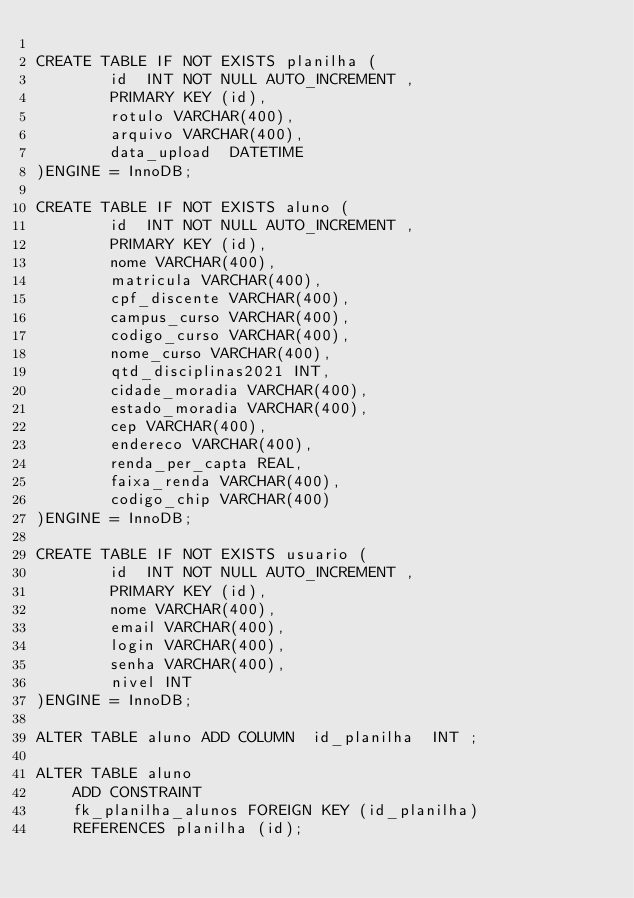Convert code to text. <code><loc_0><loc_0><loc_500><loc_500><_SQL_>
CREATE TABLE IF NOT EXISTS planilha (
        id  INT NOT NULL AUTO_INCREMENT , 
        PRIMARY KEY (id), 
        rotulo VARCHAR(400), 
        arquivo VARCHAR(400), 
        data_upload  DATETIME
)ENGINE = InnoDB;

CREATE TABLE IF NOT EXISTS aluno (
        id  INT NOT NULL AUTO_INCREMENT , 
        PRIMARY KEY (id), 
        nome VARCHAR(400), 
        matricula VARCHAR(400), 
        cpf_discente VARCHAR(400), 
        campus_curso VARCHAR(400), 
        codigo_curso VARCHAR(400), 
        nome_curso VARCHAR(400), 
        qtd_disciplinas2021 INT, 
        cidade_moradia VARCHAR(400), 
        estado_moradia VARCHAR(400), 
        cep VARCHAR(400), 
        endereco VARCHAR(400), 
        renda_per_capta REAL, 
        faixa_renda VARCHAR(400), 
        codigo_chip VARCHAR(400)
)ENGINE = InnoDB;

CREATE TABLE IF NOT EXISTS usuario (
        id  INT NOT NULL AUTO_INCREMENT , 
        PRIMARY KEY (id), 
        nome VARCHAR(400), 
        email VARCHAR(400), 
        login VARCHAR(400), 
        senha VARCHAR(400), 
        nivel INT
)ENGINE = InnoDB;

ALTER TABLE aluno ADD COLUMN  id_planilha  INT ;
                        
ALTER TABLE aluno
    ADD CONSTRAINT
    fk_planilha_alunos FOREIGN KEY (id_planilha)
    REFERENCES planilha (id);
</code> 